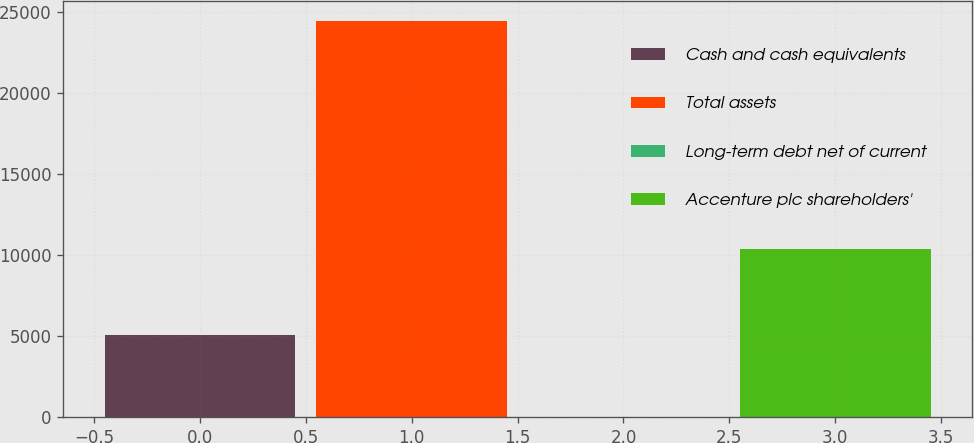Convert chart. <chart><loc_0><loc_0><loc_500><loc_500><bar_chart><fcel>Cash and cash equivalents<fcel>Total assets<fcel>Long-term debt net of current<fcel>Accenture plc shareholders'<nl><fcel>5061<fcel>24449<fcel>20<fcel>10365<nl></chart> 